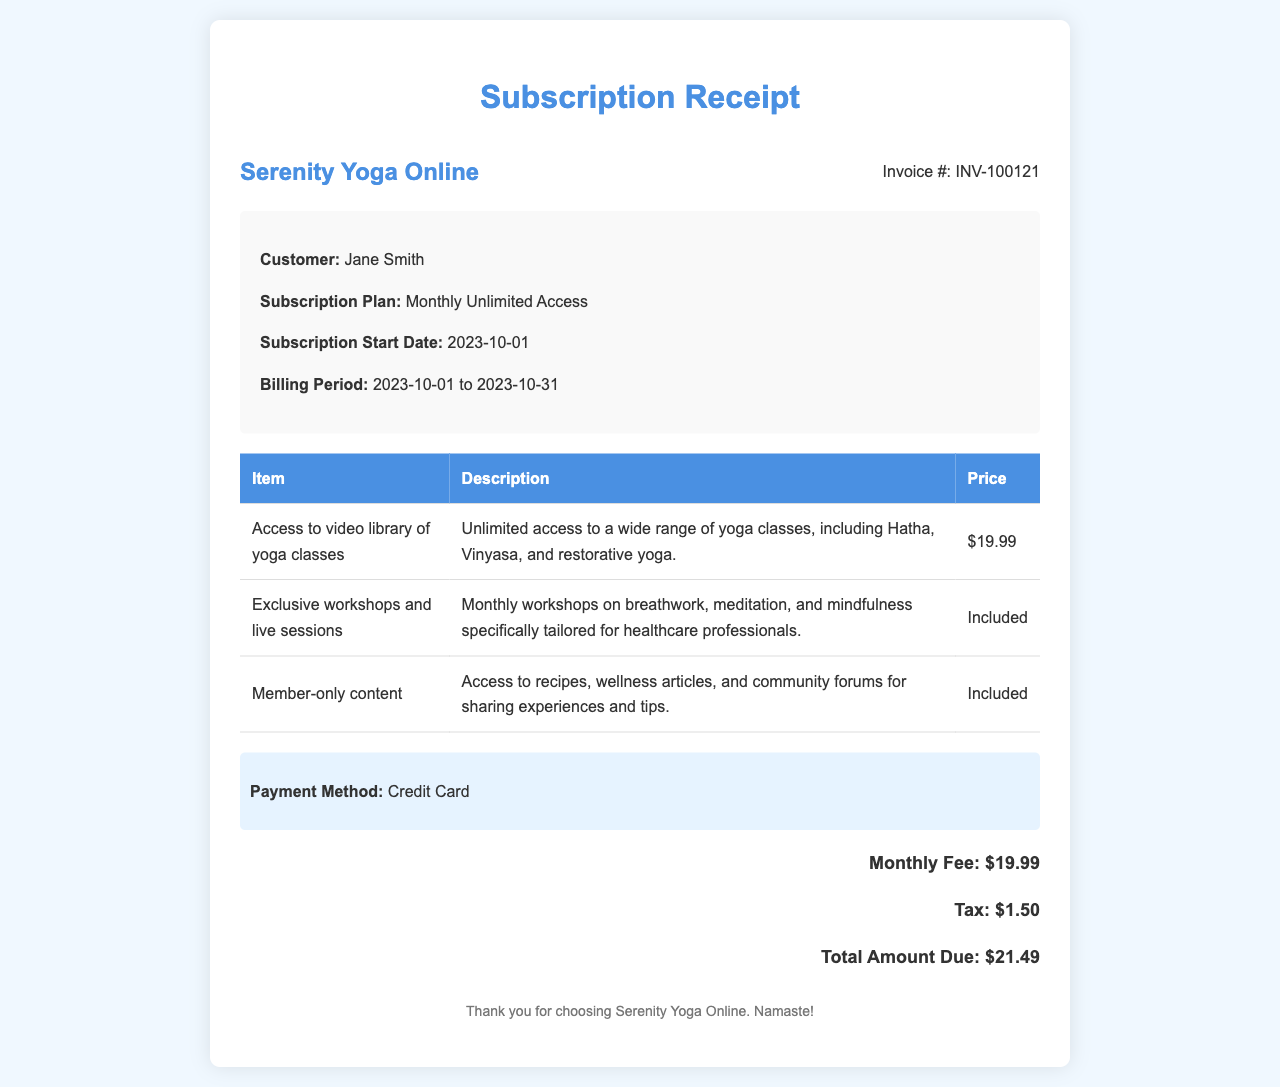What is the subscription plan? The subscription plan is mentioned in the receipt under "Subscription Plan."
Answer: Monthly Unlimited Access What is the invoice number? The invoice number is located in the header section of the receipt.
Answer: INV-100121 What is the total amount due? The total amount due is calculated at the end of the billing details section.
Answer: $21.49 What is the start date of the subscription? The subscription's start date is specified in the receipt details section.
Answer: 2023-10-01 What is included in the monthly fee? The items listed under "Table" specify what is included in the monthly fee.
Answer: Access to video library of yoga classes What payment method was used? The payment method is highlighted in the document as a separate section.
Answer: Credit Card How much is the monthly fee before tax? The monthly fee before tax is specified in the billing details.
Answer: $19.99 What exclusive content is provided? The exclusive content is described in the "Exclusive workshops and live sessions" row.
Answer: Monthly workshops on breathwork, meditation, and mindfulness What is the tax amount? The tax amount is included in the total section of the receipt.
Answer: $1.50 